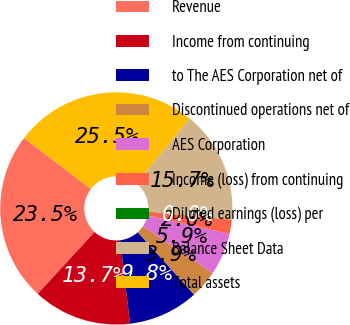Convert chart. <chart><loc_0><loc_0><loc_500><loc_500><pie_chart><fcel>Revenue<fcel>Income from continuing<fcel>to The AES Corporation net of<fcel>Discontinued operations net of<fcel>AES Corporation<fcel>Income (loss) from continuing<fcel>Diluted earnings (loss) per<fcel>Balance Sheet Data<fcel>Total assets<nl><fcel>23.53%<fcel>13.73%<fcel>9.8%<fcel>3.92%<fcel>5.88%<fcel>1.96%<fcel>0.0%<fcel>15.69%<fcel>25.49%<nl></chart> 